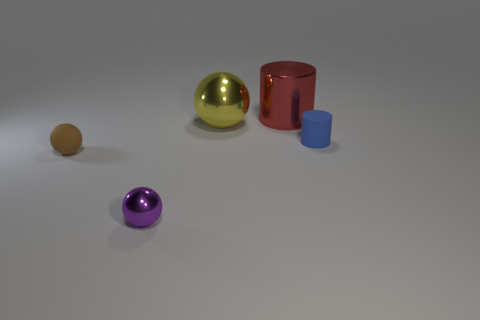Subtract all rubber balls. How many balls are left? 2 Add 4 big green rubber cubes. How many objects exist? 9 Subtract all balls. How many objects are left? 2 Subtract 0 gray spheres. How many objects are left? 5 Subtract all cylinders. Subtract all yellow matte cubes. How many objects are left? 3 Add 4 tiny matte objects. How many tiny matte objects are left? 6 Add 1 tiny green matte balls. How many tiny green matte balls exist? 1 